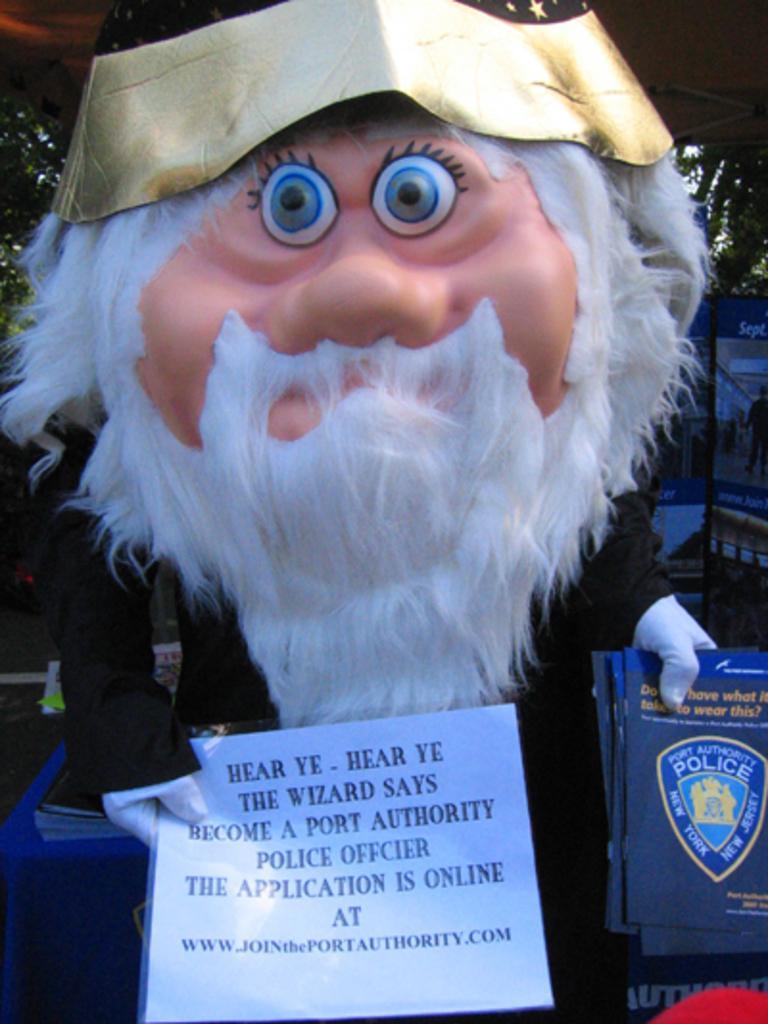How would you summarize this image in a sentence or two? In the center of the image a person is standing and wearing mask and holding the books and paper. In the background of the image we can see the boards, trees. At the bottom of the image we can see a table. On the table we can see a cloth and books. On the left side of the image we can see the ground. 